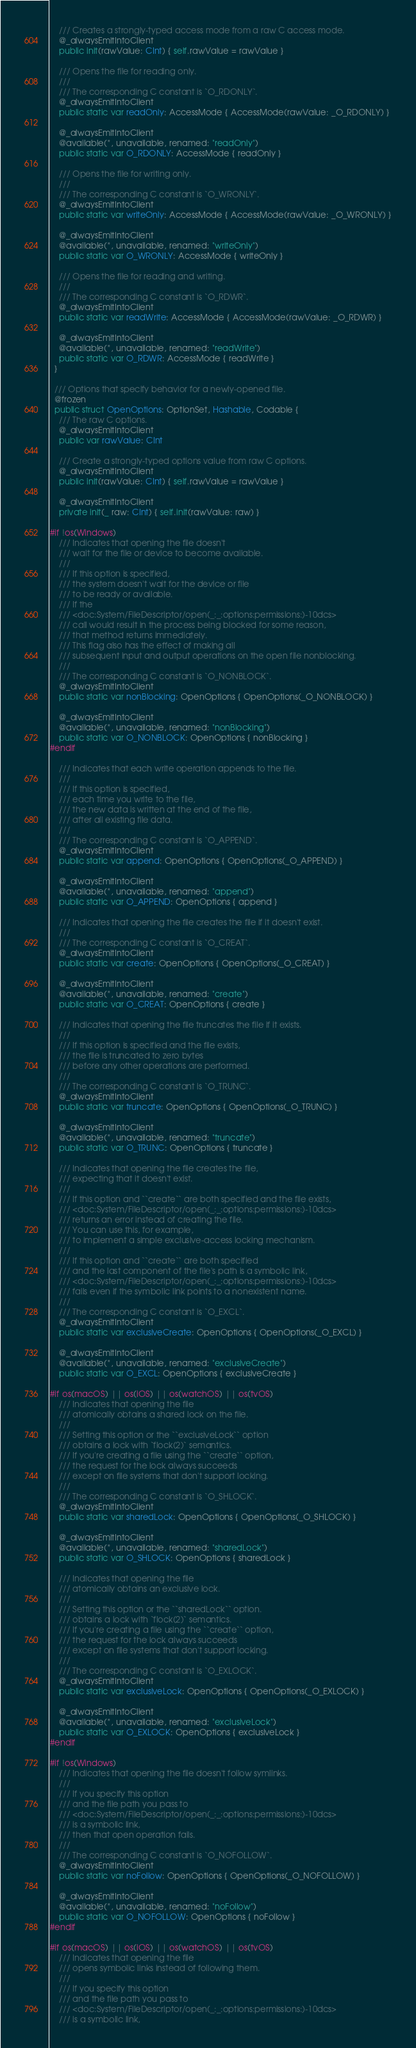<code> <loc_0><loc_0><loc_500><loc_500><_Swift_>    /// Creates a strongly-typed access mode from a raw C access mode.
    @_alwaysEmitIntoClient
    public init(rawValue: CInt) { self.rawValue = rawValue }

    /// Opens the file for reading only.
    ///
    /// The corresponding C constant is `O_RDONLY`.
    @_alwaysEmitIntoClient
    public static var readOnly: AccessMode { AccessMode(rawValue: _O_RDONLY) }

    @_alwaysEmitIntoClient
    @available(*, unavailable, renamed: "readOnly")
    public static var O_RDONLY: AccessMode { readOnly }

    /// Opens the file for writing only.
    ///
    /// The corresponding C constant is `O_WRONLY`.
    @_alwaysEmitIntoClient
    public static var writeOnly: AccessMode { AccessMode(rawValue: _O_WRONLY) }

    @_alwaysEmitIntoClient
    @available(*, unavailable, renamed: "writeOnly")
    public static var O_WRONLY: AccessMode { writeOnly }

    /// Opens the file for reading and writing.
    ///
    /// The corresponding C constant is `O_RDWR`.
    @_alwaysEmitIntoClient
    public static var readWrite: AccessMode { AccessMode(rawValue: _O_RDWR) }

    @_alwaysEmitIntoClient
    @available(*, unavailable, renamed: "readWrite")
    public static var O_RDWR: AccessMode { readWrite }
  }

  /// Options that specify behavior for a newly-opened file.
  @frozen
  public struct OpenOptions: OptionSet, Hashable, Codable {
    /// The raw C options.
    @_alwaysEmitIntoClient
    public var rawValue: CInt

    /// Create a strongly-typed options value from raw C options.
    @_alwaysEmitIntoClient
    public init(rawValue: CInt) { self.rawValue = rawValue }

    @_alwaysEmitIntoClient
    private init(_ raw: CInt) { self.init(rawValue: raw) }

#if !os(Windows)
    /// Indicates that opening the file doesn't
    /// wait for the file or device to become available.
    ///
    /// If this option is specified,
    /// the system doesn't wait for the device or file
    /// to be ready or available.
    /// If the
    /// <doc:System/FileDescriptor/open(_:_:options:permissions:)-10dcs>
    /// call would result in the process being blocked for some reason,
    /// that method returns immediately.
    /// This flag also has the effect of making all
    /// subsequent input and output operations on the open file nonblocking.
    ///
    /// The corresponding C constant is `O_NONBLOCK`.
    @_alwaysEmitIntoClient
    public static var nonBlocking: OpenOptions { OpenOptions(_O_NONBLOCK) }

    @_alwaysEmitIntoClient
    @available(*, unavailable, renamed: "nonBlocking")
    public static var O_NONBLOCK: OpenOptions { nonBlocking }
#endif

    /// Indicates that each write operation appends to the file.
    ///
    /// If this option is specified,
    /// each time you write to the file,
    /// the new data is written at the end of the file,
    /// after all existing file data.
    ///
    /// The corresponding C constant is `O_APPEND`.
    @_alwaysEmitIntoClient
    public static var append: OpenOptions { OpenOptions(_O_APPEND) }

    @_alwaysEmitIntoClient
    @available(*, unavailable, renamed: "append")
    public static var O_APPEND: OpenOptions { append }

    /// Indicates that opening the file creates the file if it doesn't exist.
    ///
    /// The corresponding C constant is `O_CREAT`.
    @_alwaysEmitIntoClient
    public static var create: OpenOptions { OpenOptions(_O_CREAT) }

    @_alwaysEmitIntoClient
    @available(*, unavailable, renamed: "create")
    public static var O_CREAT: OpenOptions { create }

    /// Indicates that opening the file truncates the file if it exists.
    ///
    /// If this option is specified and the file exists,
    /// the file is truncated to zero bytes
    /// before any other operations are performed.
    ///
    /// The corresponding C constant is `O_TRUNC`.
    @_alwaysEmitIntoClient
    public static var truncate: OpenOptions { OpenOptions(_O_TRUNC) }

    @_alwaysEmitIntoClient
    @available(*, unavailable, renamed: "truncate")
    public static var O_TRUNC: OpenOptions { truncate }

    /// Indicates that opening the file creates the file,
    /// expecting that it doesn't exist.
    ///
    /// If this option and ``create`` are both specified and the file exists,
    /// <doc:System/FileDescriptor/open(_:_:options:permissions:)-10dcs>
    /// returns an error instead of creating the file.
    /// You can use this, for example,
    /// to implement a simple exclusive-access locking mechanism.
    ///
    /// If this option and ``create`` are both specified
    /// and the last component of the file's path is a symbolic link,
    /// <doc:System/FileDescriptor/open(_:_:options:permissions:)-10dcs>
    /// fails even if the symbolic link points to a nonexistent name.
    ///
    /// The corresponding C constant is `O_EXCL`.
    @_alwaysEmitIntoClient
    public static var exclusiveCreate: OpenOptions { OpenOptions(_O_EXCL) }

    @_alwaysEmitIntoClient
    @available(*, unavailable, renamed: "exclusiveCreate")
    public static var O_EXCL: OpenOptions { exclusiveCreate }

#if os(macOS) || os(iOS) || os(watchOS) || os(tvOS)
    /// Indicates that opening the file
    /// atomically obtains a shared lock on the file.
    ///
    /// Setting this option or the ``exclusiveLock`` option
    /// obtains a lock with `flock(2)` semantics.
    /// If you're creating a file using the ``create`` option,
    /// the request for the lock always succeeds
    /// except on file systems that don't support locking.
    ///
    /// The corresponding C constant is `O_SHLOCK`.
    @_alwaysEmitIntoClient
    public static var sharedLock: OpenOptions { OpenOptions(_O_SHLOCK) }

    @_alwaysEmitIntoClient
    @available(*, unavailable, renamed: "sharedLock")
    public static var O_SHLOCK: OpenOptions { sharedLock }

    /// Indicates that opening the file
    /// atomically obtains an exclusive lock.
    ///
    /// Setting this option or the ``sharedLock`` option.
    /// obtains a lock with `flock(2)` semantics.
    /// If you're creating a file using the ``create`` option,
    /// the request for the lock always succeeds
    /// except on file systems that don't support locking.
    ///
    /// The corresponding C constant is `O_EXLOCK`.
    @_alwaysEmitIntoClient
    public static var exclusiveLock: OpenOptions { OpenOptions(_O_EXLOCK) }

    @_alwaysEmitIntoClient
    @available(*, unavailable, renamed: "exclusiveLock")
    public static var O_EXLOCK: OpenOptions { exclusiveLock }
#endif

#if !os(Windows)
    /// Indicates that opening the file doesn't follow symlinks.
    ///
    /// If you specify this option
    /// and the file path you pass to
    /// <doc:System/FileDescriptor/open(_:_:options:permissions:)-10dcs>
    /// is a symbolic link,
    /// then that open operation fails.
    ///
    /// The corresponding C constant is `O_NOFOLLOW`.
    @_alwaysEmitIntoClient
    public static var noFollow: OpenOptions { OpenOptions(_O_NOFOLLOW) }

    @_alwaysEmitIntoClient
    @available(*, unavailable, renamed: "noFollow")
    public static var O_NOFOLLOW: OpenOptions { noFollow }
#endif

#if os(macOS) || os(iOS) || os(watchOS) || os(tvOS)
    /// Indicates that opening the file
    /// opens symbolic links instead of following them.
    ///
    /// If you specify this option
    /// and the file path you pass to
    /// <doc:System/FileDescriptor/open(_:_:options:permissions:)-10dcs>
    /// is a symbolic link,</code> 